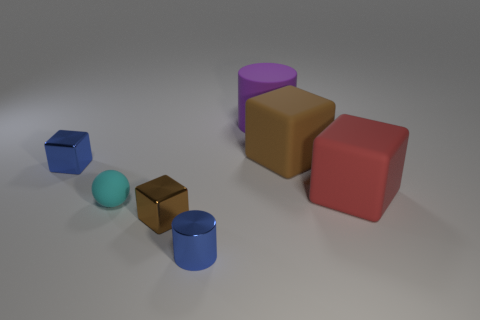Subtract all tiny brown cubes. How many cubes are left? 3 Add 1 small cyan rubber things. How many objects exist? 8 Subtract 1 spheres. How many spheres are left? 0 Subtract all blue blocks. How many blue spheres are left? 0 Subtract all yellow rubber blocks. Subtract all small metallic objects. How many objects are left? 4 Add 4 blue metal cubes. How many blue metal cubes are left? 5 Add 6 big blue objects. How many big blue objects exist? 6 Subtract all brown blocks. How many blocks are left? 2 Subtract 1 cyan spheres. How many objects are left? 6 Subtract all cubes. How many objects are left? 3 